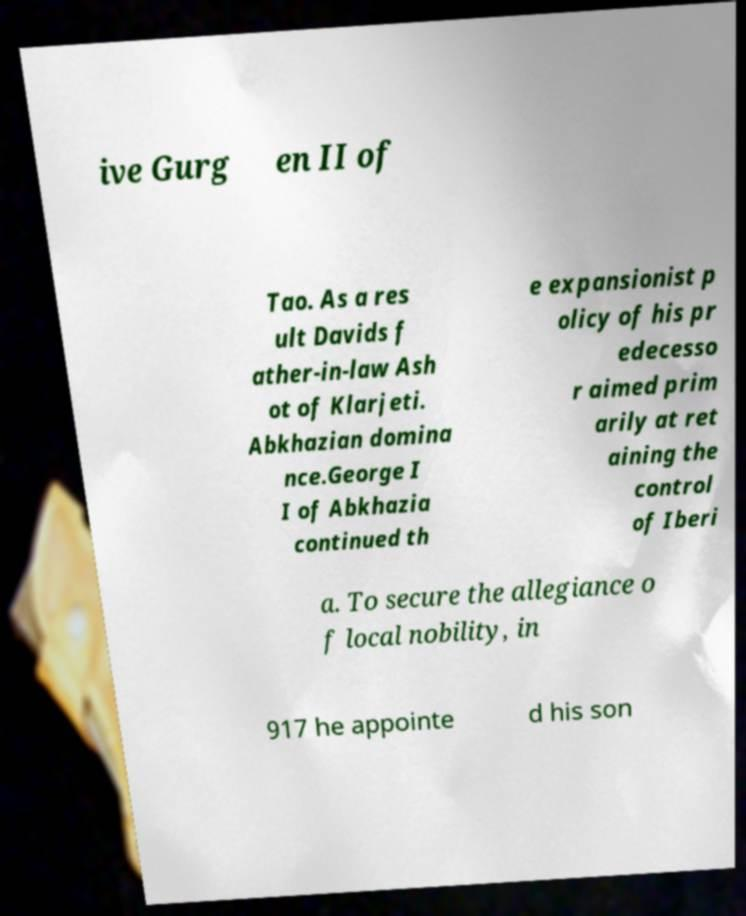There's text embedded in this image that I need extracted. Can you transcribe it verbatim? ive Gurg en II of Tao. As a res ult Davids f ather-in-law Ash ot of Klarjeti. Abkhazian domina nce.George I I of Abkhazia continued th e expansionist p olicy of his pr edecesso r aimed prim arily at ret aining the control of Iberi a. To secure the allegiance o f local nobility, in 917 he appointe d his son 